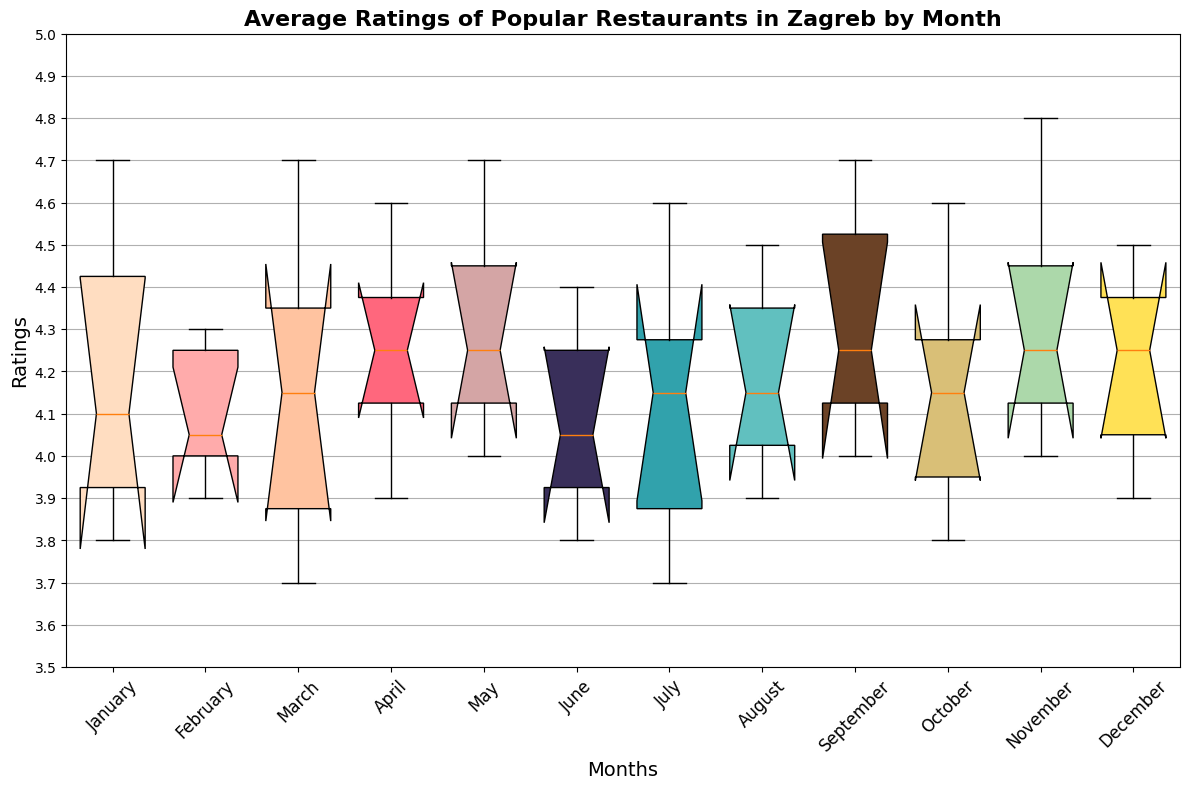What is the range of ratings in February? To find the range, we subtract the lowest rating from the highest rating in February. The ratings are: 4.1, 4.3, 4.0, 3.9, 4.8, and 4.0. Thus, the range is 4.8 - 3.9 = 0.9.
Answer: 0.9 Which month has the highest median rating? To identify the month with the highest median rating, examine the middle line inside each box plot which represents the median. From the plot, November has the highest median as it visually appears higher compared to other months.
Answer: November Is the interquartile range (IQR) in April greater than in January? The IQR is the distance between the first quartile (Q1) and the third quartile (Q3). In the plot, comparing the IQR (box height) of April to January, April's IQR is visually smaller. Thus, January has a larger IQR than April.
Answer: No Which month shows the most consistency in restaurant ratings (smallest IQR)? Consistency can be observed through the smallest IQR, meaning the smallest height of the box in the plot. From the boxes, February shows the most consistency in restaurant ratings as it has the smallest IQR.
Answer: February What is the median rating for May? Identify May in the plot and look at the line inside the box representing the median. For May, the median rating is aligned around the value of 4.3.
Answer: 4.3 How do the median ratings in March compare to those in September? Compare the horizontal positions of the medians (lines inside the boxes) for March and September. March's median is lower than September's median line.
Answer: March < September In which months does Restaurant E have the highest rating? Check each section for the highest point related to Restaurant E's color. From the plot, February and November show the highest point within their respective plots for Restaurant E.
Answer: February and November What is the difference between the maximum rating in July and the minimum rating in June? Identify the highest point in July and the lowest point in June. The maximum in July is 4.6, in June the minimum is 3.8. The difference is 4.6 - 3.8 = 0.8.
Answer: 0.8 Which month has the widest range of ratings? The widest range can be observed where the distance between the minimum and the maximum is the greatest (height of lines extending from the box). From the plot, February seems to have the widest range.
Answer: February 